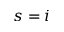<formula> <loc_0><loc_0><loc_500><loc_500>s = i</formula> 